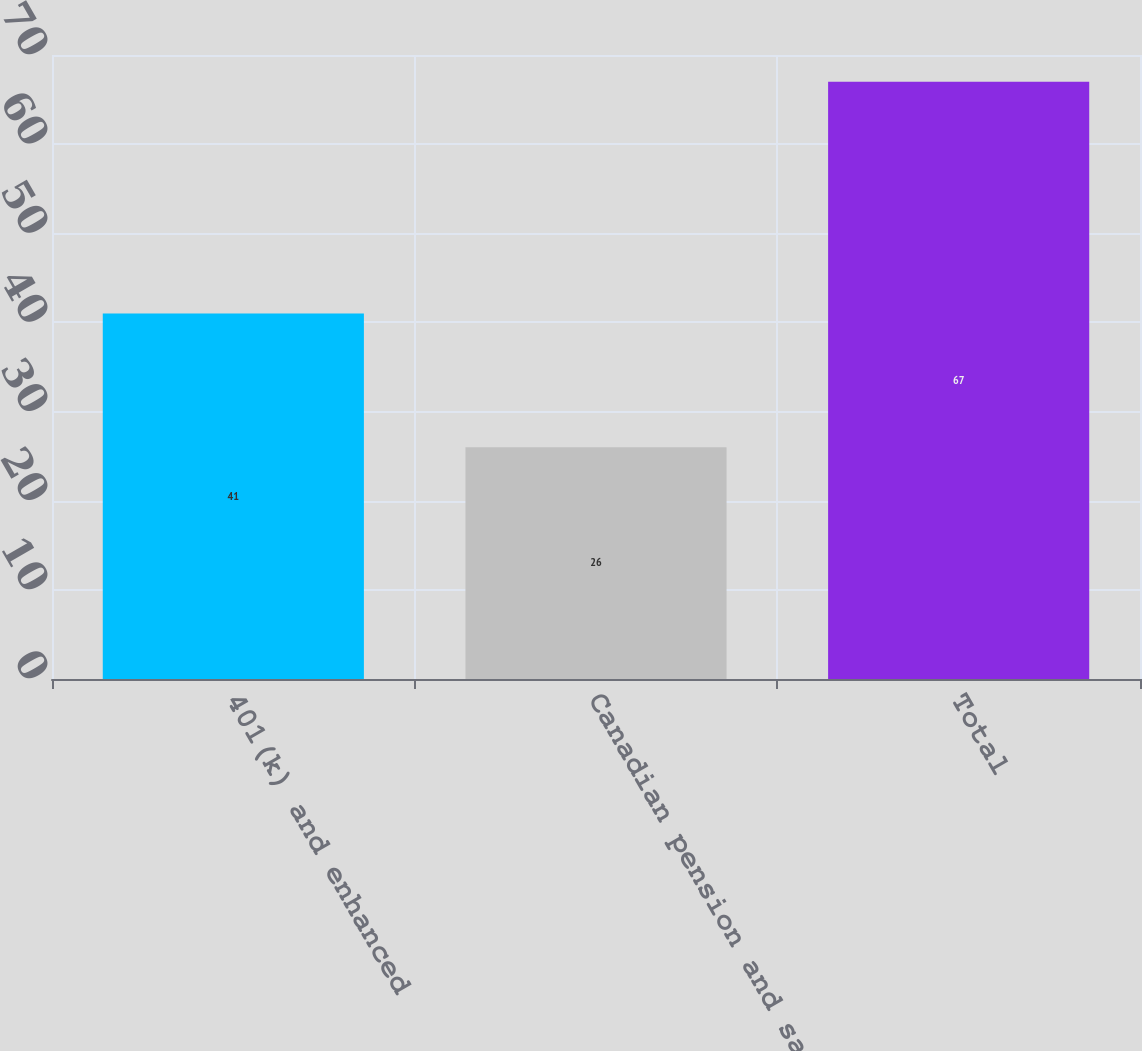Convert chart. <chart><loc_0><loc_0><loc_500><loc_500><bar_chart><fcel>401(k) and enhanced<fcel>Canadian pension and savings<fcel>Total<nl><fcel>41<fcel>26<fcel>67<nl></chart> 